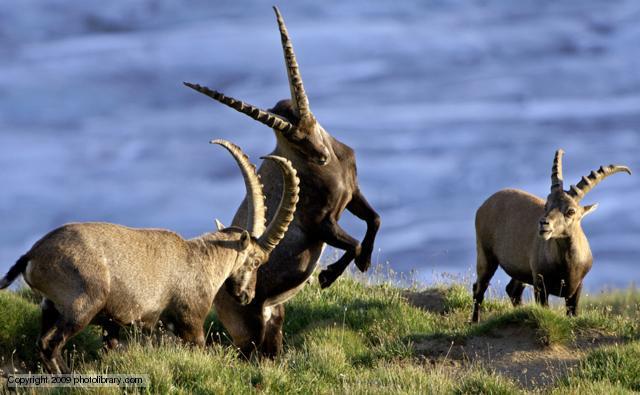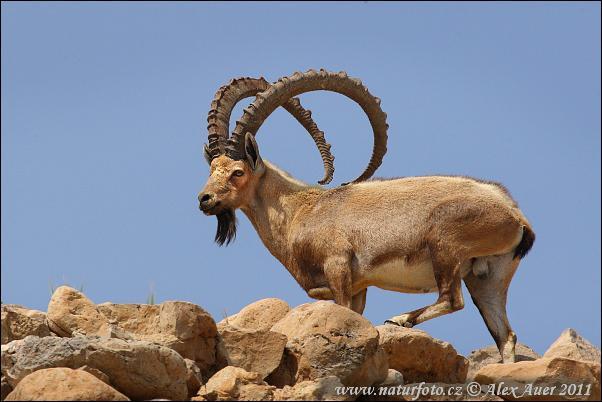The first image is the image on the left, the second image is the image on the right. Examine the images to the left and right. Is the description "Two rams are facing each other on top of a boulder in the mountains in one image." accurate? Answer yes or no. No. The first image is the image on the left, the second image is the image on the right. Considering the images on both sides, is "In at least one image there is a lone Ibex on rocky ground" valid? Answer yes or no. Yes. 